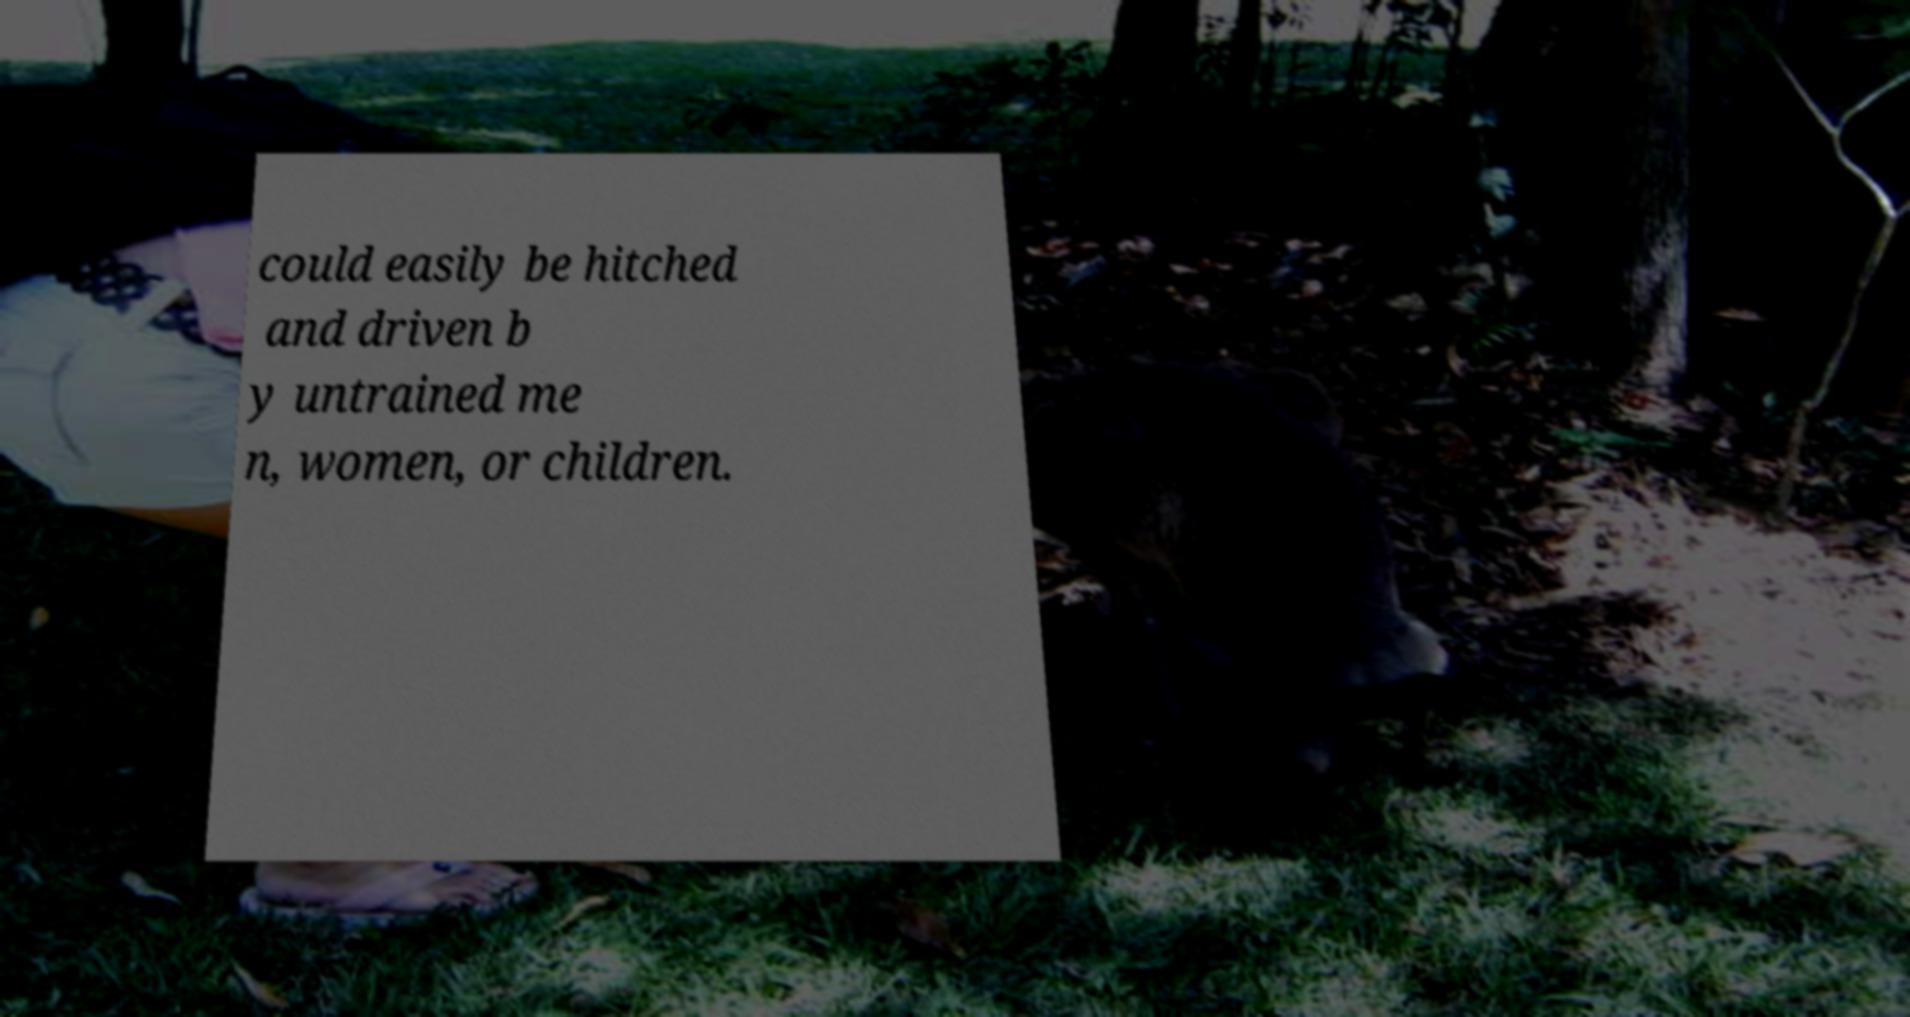Could you assist in decoding the text presented in this image and type it out clearly? could easily be hitched and driven b y untrained me n, women, or children. 